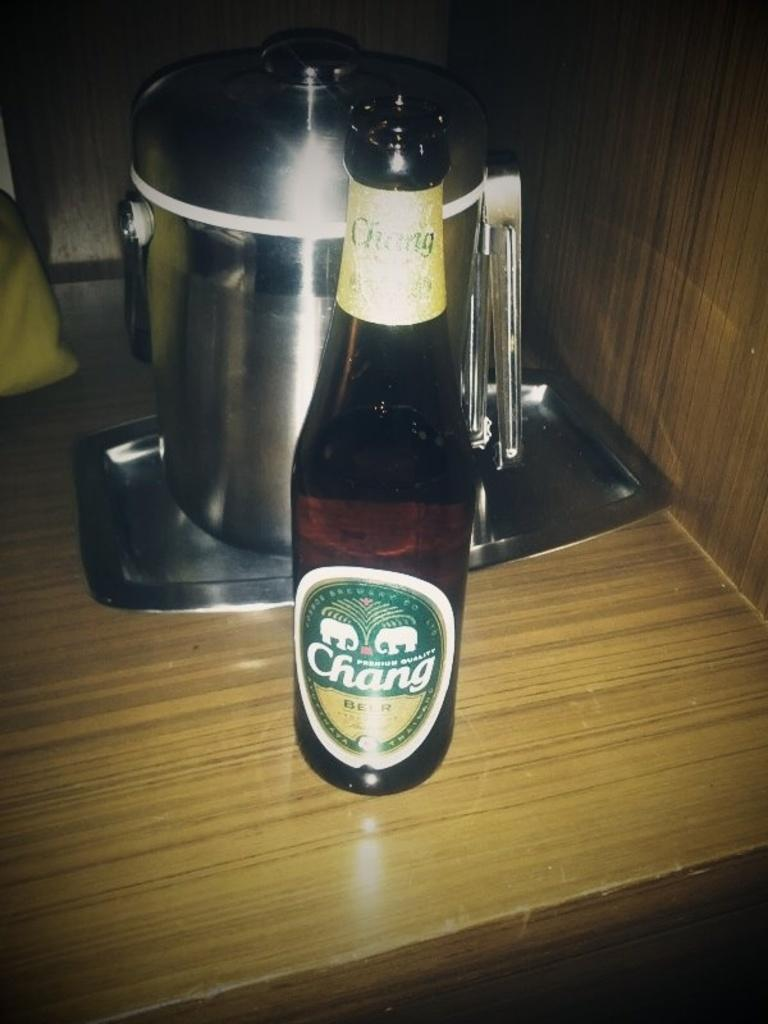<image>
Relay a brief, clear account of the picture shown. Bottle with a green tag that says CHANG. 